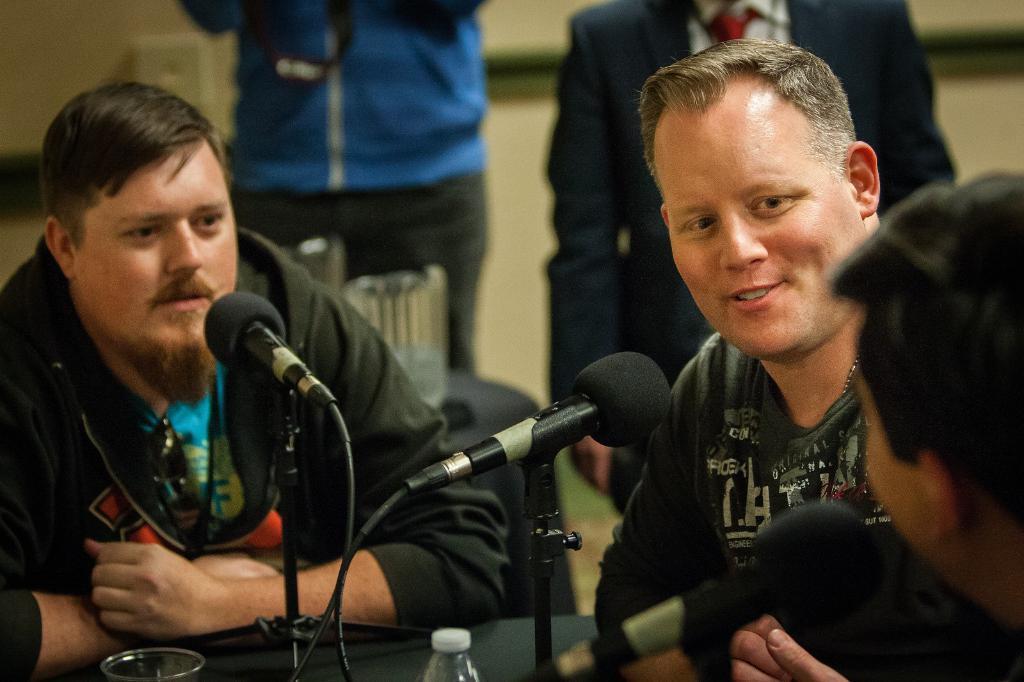Describe this image in one or two sentences. This image consists of three men sitting and talking. In front of them, there are mics. At the bottom, we can see a glass and bottle are kept on the table. On the left, the man is wearing a black jacket. In the background, there are two persons standing. 